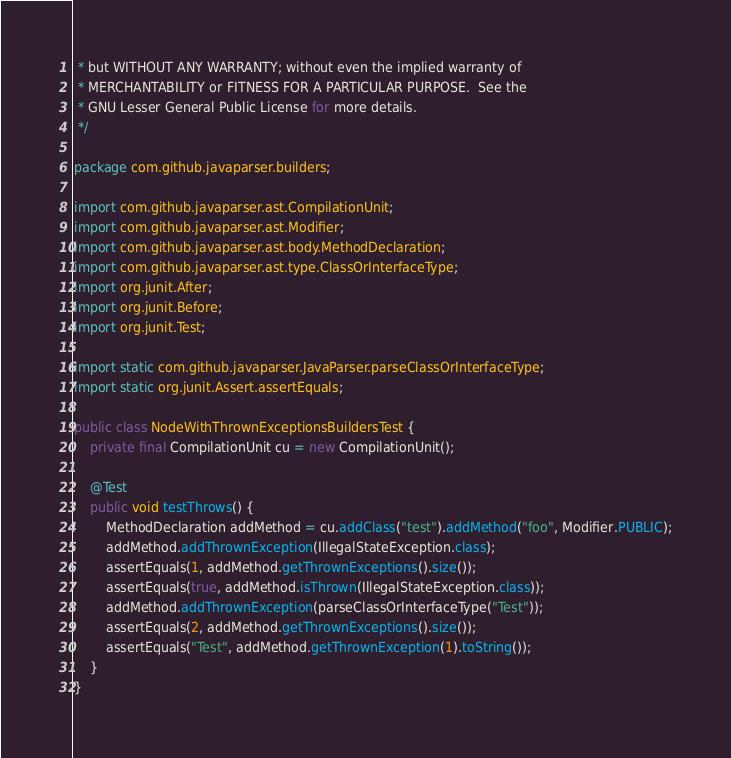Convert code to text. <code><loc_0><loc_0><loc_500><loc_500><_Java_> * but WITHOUT ANY WARRANTY; without even the implied warranty of
 * MERCHANTABILITY or FITNESS FOR A PARTICULAR PURPOSE.  See the
 * GNU Lesser General Public License for more details.
 */

package com.github.javaparser.builders;

import com.github.javaparser.ast.CompilationUnit;
import com.github.javaparser.ast.Modifier;
import com.github.javaparser.ast.body.MethodDeclaration;
import com.github.javaparser.ast.type.ClassOrInterfaceType;
import org.junit.After;
import org.junit.Before;
import org.junit.Test;

import static com.github.javaparser.JavaParser.parseClassOrInterfaceType;
import static org.junit.Assert.assertEquals;

public class NodeWithThrownExceptionsBuildersTest {
    private final CompilationUnit cu = new CompilationUnit();

    @Test
    public void testThrows() {
        MethodDeclaration addMethod = cu.addClass("test").addMethod("foo", Modifier.PUBLIC);
        addMethod.addThrownException(IllegalStateException.class);
        assertEquals(1, addMethod.getThrownExceptions().size());
        assertEquals(true, addMethod.isThrown(IllegalStateException.class));
        addMethod.addThrownException(parseClassOrInterfaceType("Test"));
        assertEquals(2, addMethod.getThrownExceptions().size());
        assertEquals("Test", addMethod.getThrownException(1).toString());
    }
}
</code> 